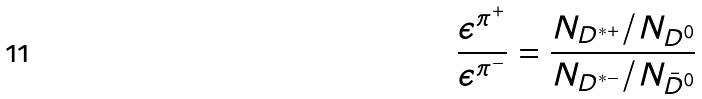Convert formula to latex. <formula><loc_0><loc_0><loc_500><loc_500>\frac { \epsilon ^ { \pi ^ { + } } } { \epsilon ^ { \pi ^ { - } } } = \frac { N _ { D ^ { * + } } / N _ { D ^ { 0 } } } { N _ { D ^ { * - } } / N _ { \bar { D } ^ { 0 } } }</formula> 